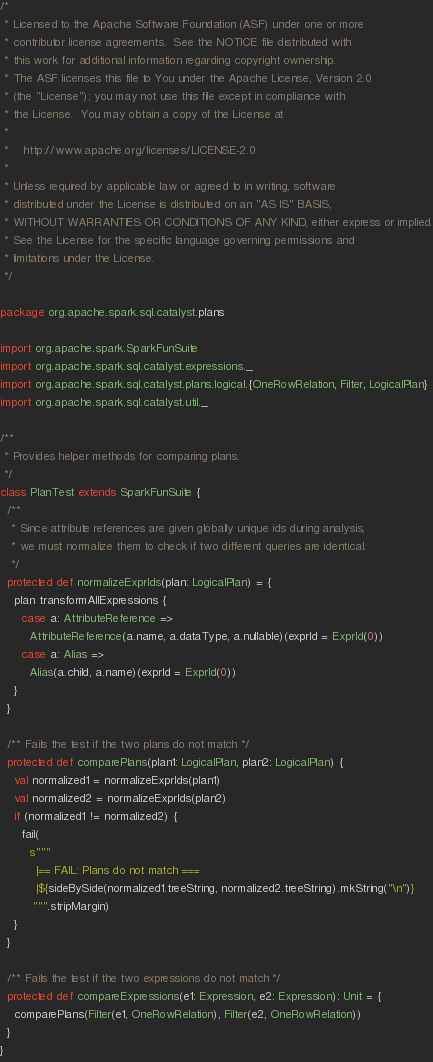Convert code to text. <code><loc_0><loc_0><loc_500><loc_500><_Scala_>/*
 * Licensed to the Apache Software Foundation (ASF) under one or more
 * contributor license agreements.  See the NOTICE file distributed with
 * this work for additional information regarding copyright ownership.
 * The ASF licenses this file to You under the Apache License, Version 2.0
 * (the "License"); you may not use this file except in compliance with
 * the License.  You may obtain a copy of the License at
 *
 *    http://www.apache.org/licenses/LICENSE-2.0
 *
 * Unless required by applicable law or agreed to in writing, software
 * distributed under the License is distributed on an "AS IS" BASIS,
 * WITHOUT WARRANTIES OR CONDITIONS OF ANY KIND, either express or implied.
 * See the License for the specific language governing permissions and
 * limitations under the License.
 */

package org.apache.spark.sql.catalyst.plans

import org.apache.spark.SparkFunSuite
import org.apache.spark.sql.catalyst.expressions._
import org.apache.spark.sql.catalyst.plans.logical.{OneRowRelation, Filter, LogicalPlan}
import org.apache.spark.sql.catalyst.util._

/**
 * Provides helper methods for comparing plans.
 */
class PlanTest extends SparkFunSuite {
  /**
   * Since attribute references are given globally unique ids during analysis,
   * we must normalize them to check if two different queries are identical.
   */
  protected def normalizeExprIds(plan: LogicalPlan) = {
    plan transformAllExpressions {
      case a: AttributeReference =>
        AttributeReference(a.name, a.dataType, a.nullable)(exprId = ExprId(0))
      case a: Alias =>
        Alias(a.child, a.name)(exprId = ExprId(0))
    }
  }

  /** Fails the test if the two plans do not match */
  protected def comparePlans(plan1: LogicalPlan, plan2: LogicalPlan) {
    val normalized1 = normalizeExprIds(plan1)
    val normalized2 = normalizeExprIds(plan2)
    if (normalized1 != normalized2) {
      fail(
        s"""
          |== FAIL: Plans do not match ===
          |${sideBySide(normalized1.treeString, normalized2.treeString).mkString("\n")}
         """.stripMargin)
    }
  }

  /** Fails the test if the two expressions do not match */
  protected def compareExpressions(e1: Expression, e2: Expression): Unit = {
    comparePlans(Filter(e1, OneRowRelation), Filter(e2, OneRowRelation))
  }
}
</code> 